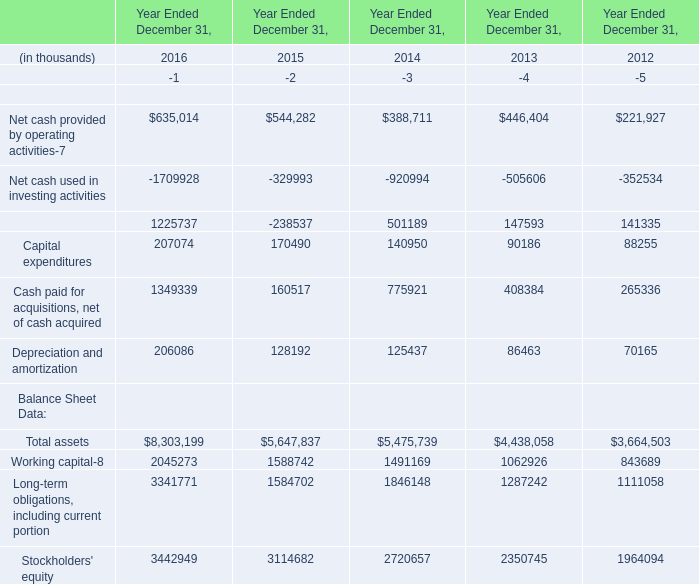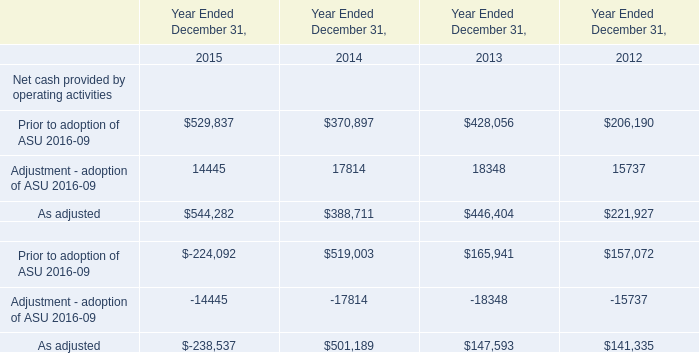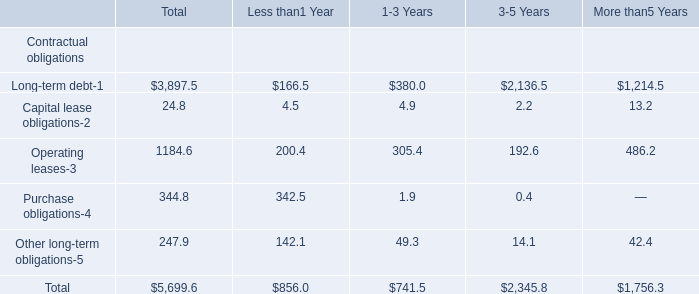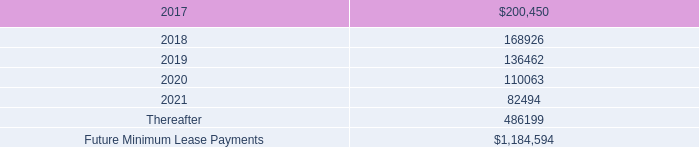In the year with the most Total assets, what is the growth rate of Working capital? (in %) 
Computations: ((2045273 - 1588742) / 1588742)
Answer: 0.28735. 